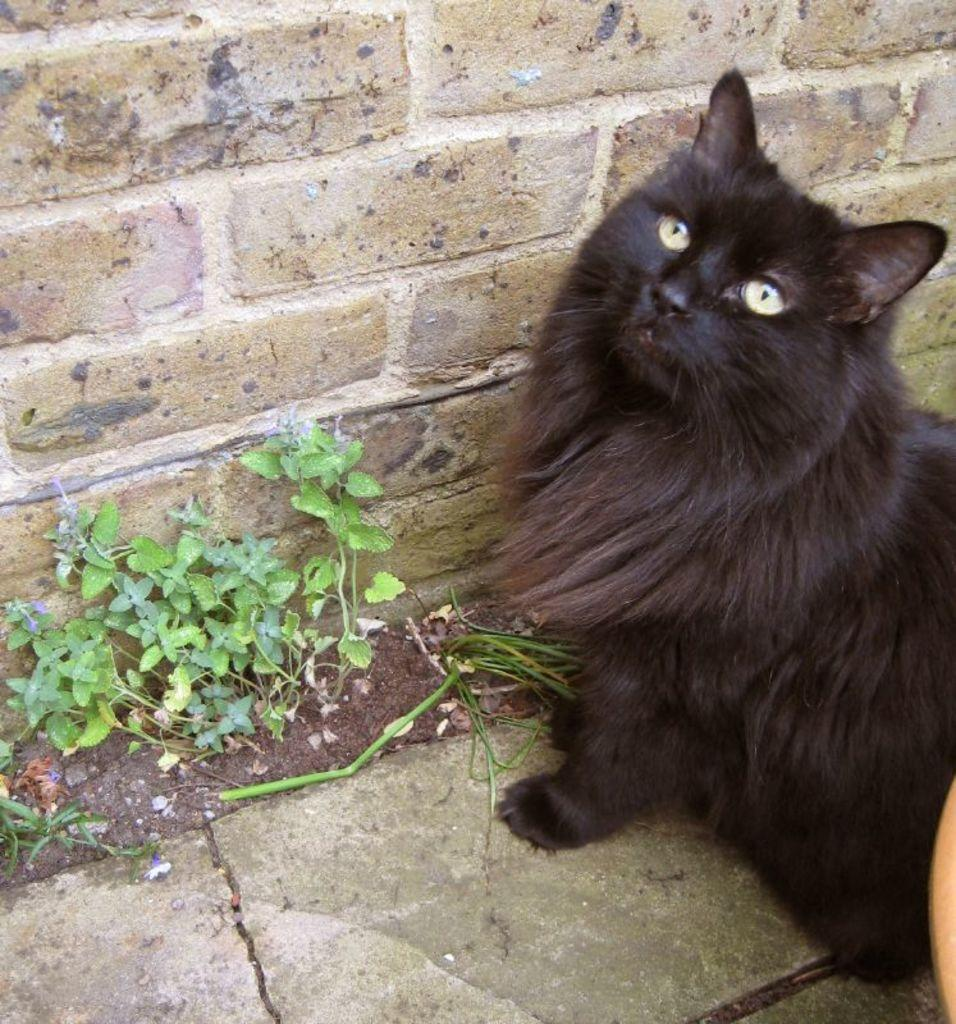What type of animal is in the image? There is a black cat in the image. What else can be seen in the image besides the black cat? There are small plants in the image. Where are the plants located in relation to the black cat? The plants are beside the black cat. What is visible behind the plants in the image? There is a wall visible behind the plants. What type of grape is the boy offering to the black cat in the image? There is no boy or grape present in the image; it only features a black cat and small plants. 